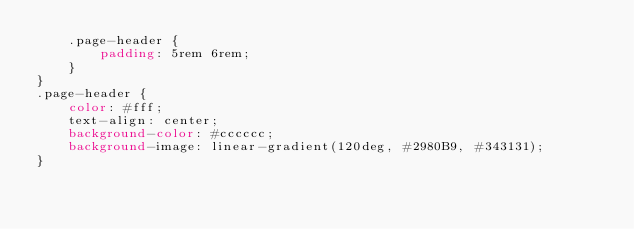<code> <loc_0><loc_0><loc_500><loc_500><_CSS_>    .page-header {
        padding: 5rem 6rem;
    }
}
.page-header {
    color: #fff;
    text-align: center;
    background-color: #cccccc;
    background-image: linear-gradient(120deg, #2980B9, #343131);
}</code> 